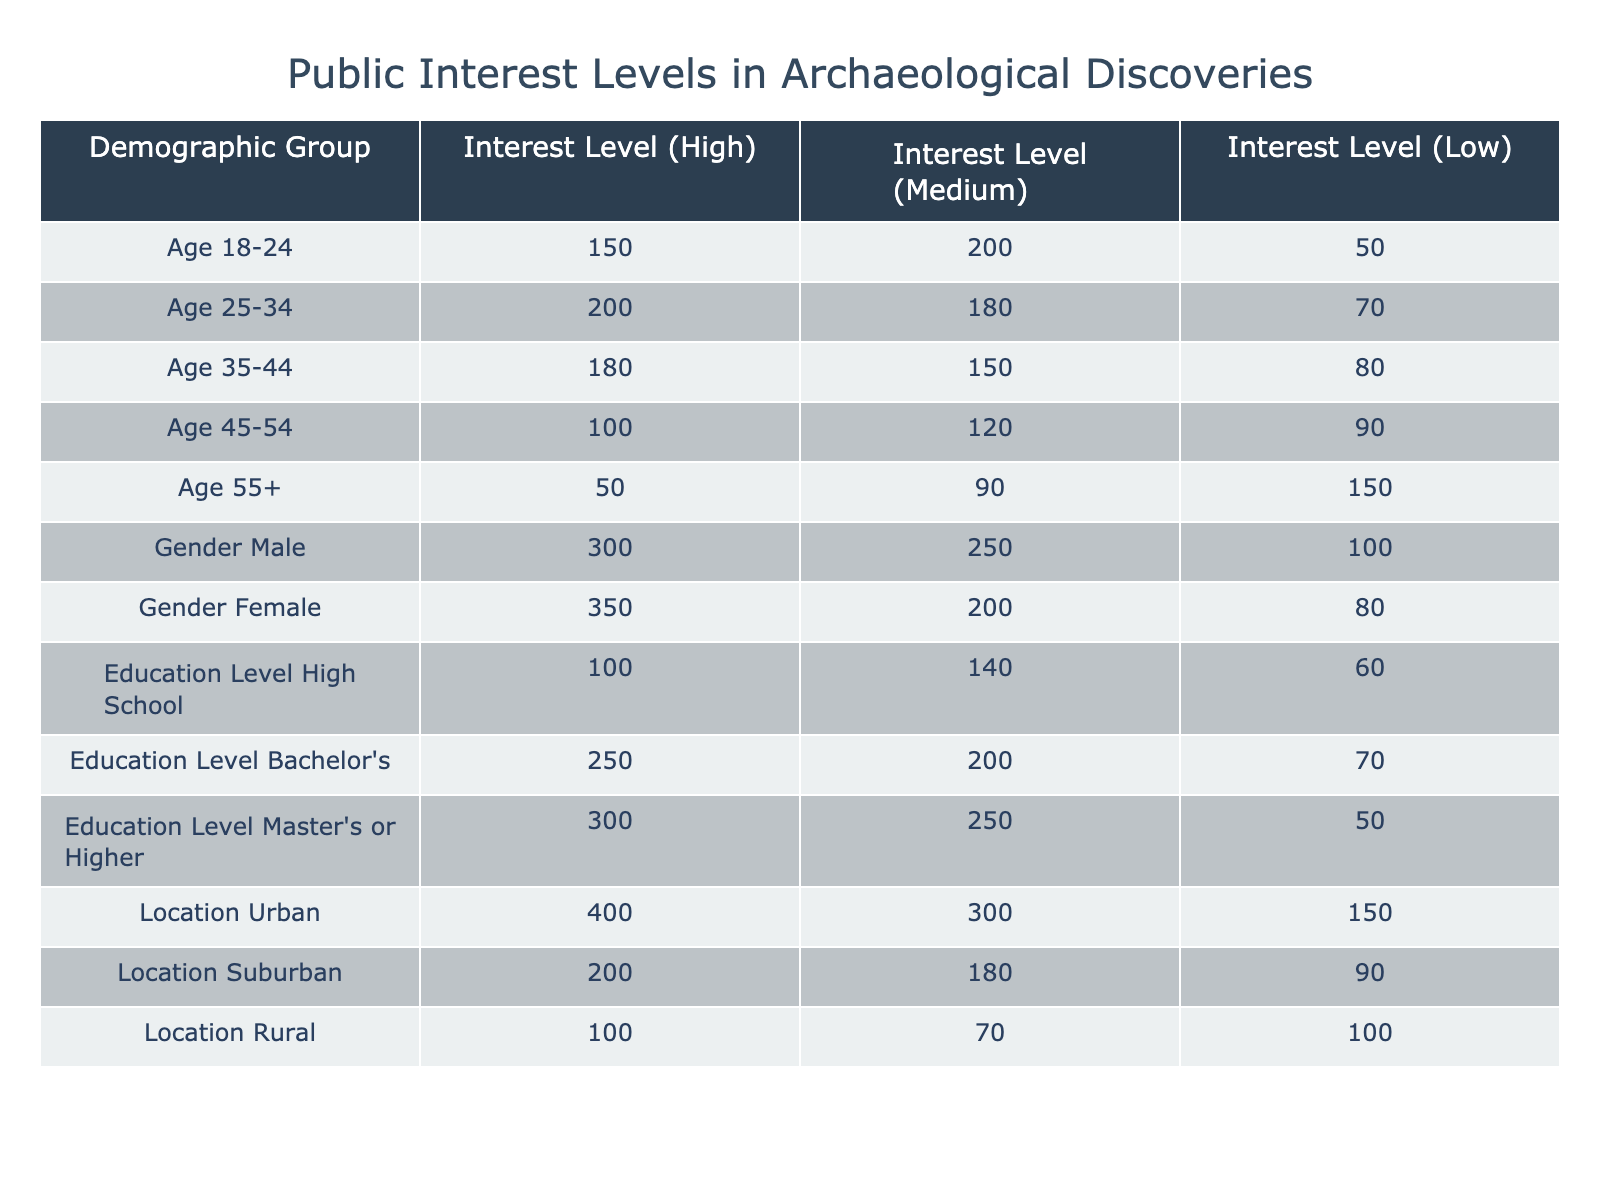What demographic group has the highest level of public interest (high interest) in archaeological discoveries? Looking at the "Interest Level (High)" column in the table, the "Gender Female" row has the highest value of 350.
Answer: Gender Female What is the total number of people from the age group 35-44 who expressed medium and high interest in archaeology? The values for "Age 35-44" in the "Interest Level (Medium)" and "Interest Level (High)" columns are 150 and 180, respectively. Adding these together gives 150 + 180 = 330.
Answer: 330 Is it true that the urban demographic shows a higher interest in archaeology compared to the rural demographic? Comparing the "Urban" row with the "Rural" row in the "Interest Level (High)" column, Urban (400) is greater than Rural (100), confirming the statement is true.
Answer: Yes What percentage of males expressed low interest in archaeological discoveries? The number of males with low interest is 100, and the total interest for males is (300 + 250 + 100) = 650. The percentage can be calculated as (100 / 650) * 100 = 15.38%.
Answer: 15.38% Which demographic group has the lowest average interest level across all categories? Calculating the average for each group: Age 55+ is (50 + 90 + 150) / 3 = 96.67. This is the lowest average when compared with other groups.
Answer: Age 55+ What is the difference between the high interest levels in archaeology for gender groups (Male vs Female)? For "Gender Male" the high interest level is 300, and for "Gender Female" it is 350. The difference is calculated as 350 - 300 = 50.
Answer: 50 What is the combined low interest total for all education levels? Adding the low interest values from each education level: 60 (High School) + 70 (Bachelor's) + 50 (Master's or Higher) = 180.
Answer: 180 In terms of location, how does the total medium interest compare between urban and suburban demographics? The medium interest for Urban is 300 and for Suburban is 180. Urban has a higher medium interest level by 120.
Answer: Urban has higher by 120 What is the highest level of interest expressed across all demographics? The highest level of interest in the "Interest Level (High)" column is 400, contributed by the Urban demographic group.
Answer: 400 